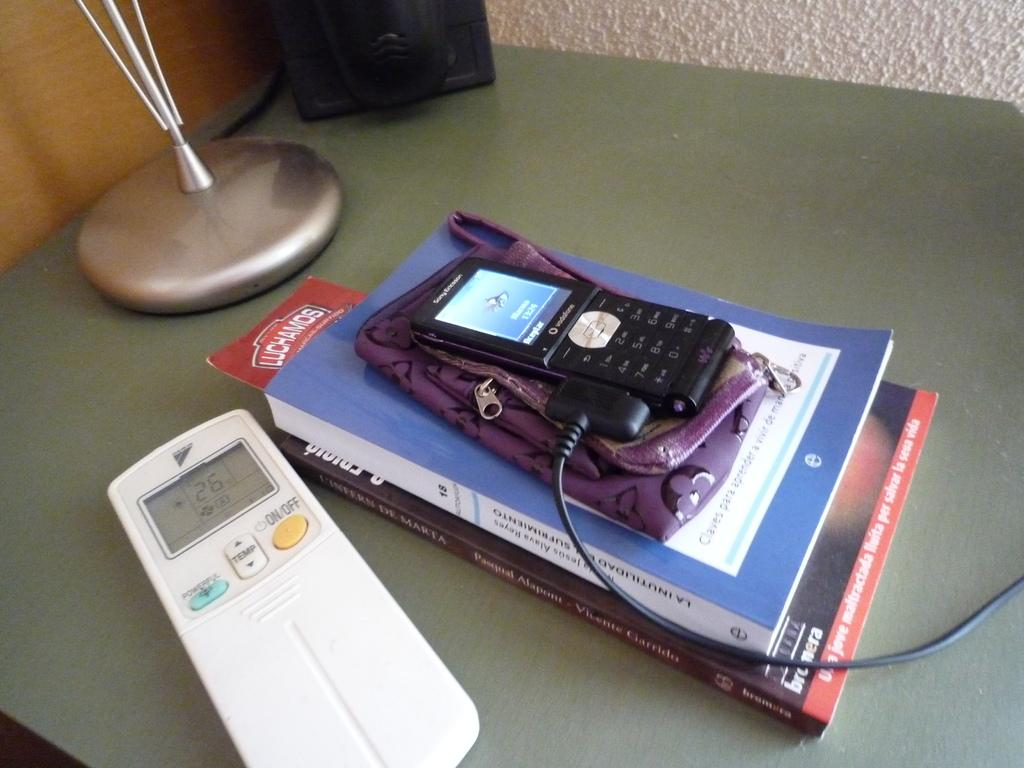What electronic device is visible in the image? There is a mobile phone in the image. What type of items can be seen besides the mobile phone? There are books and a remote in the image. What is the surface made of that the items are placed on? The wooden surface in the image. Can you describe any other objects on the wooden surface? There are other objects on the wooden surface in the image, but their specific details are not mentioned in the provided facts. How does the mobile phone twist in the image? The mobile phone does not twist in the image; it is stationary on the wooden surface. 